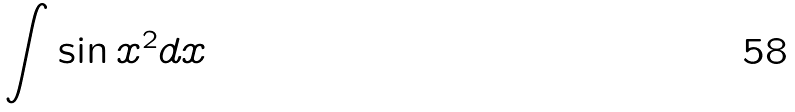<formula> <loc_0><loc_0><loc_500><loc_500>\int \sin x ^ { 2 } d x</formula> 